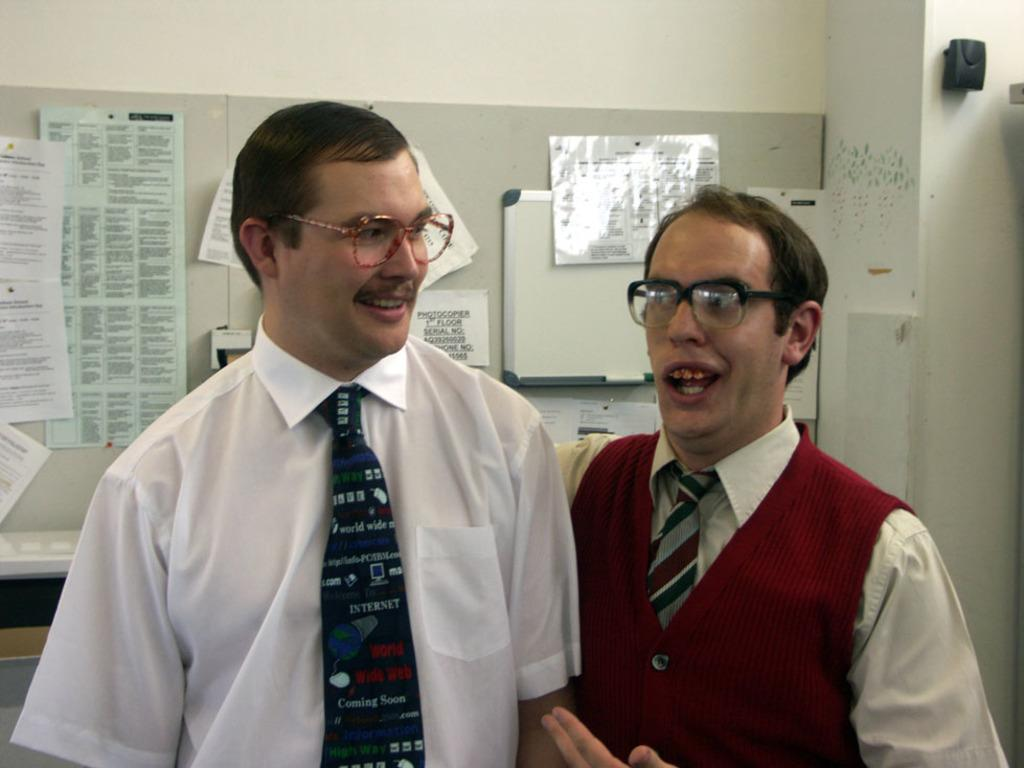How many people are present in the image? There are two people standing in the image. What can be seen in the background of the image? There is a wall with a board and papers in the background. What color is the object attached to the wall? The object attached to the wall is black. What type of ear is visible on the cow in the image? There is no cow or ear present in the image; it features two people and a wall with a board and papers. What hobbies do the people in the image have? The provided facts do not give any information about the hobbies of the people in the image. 